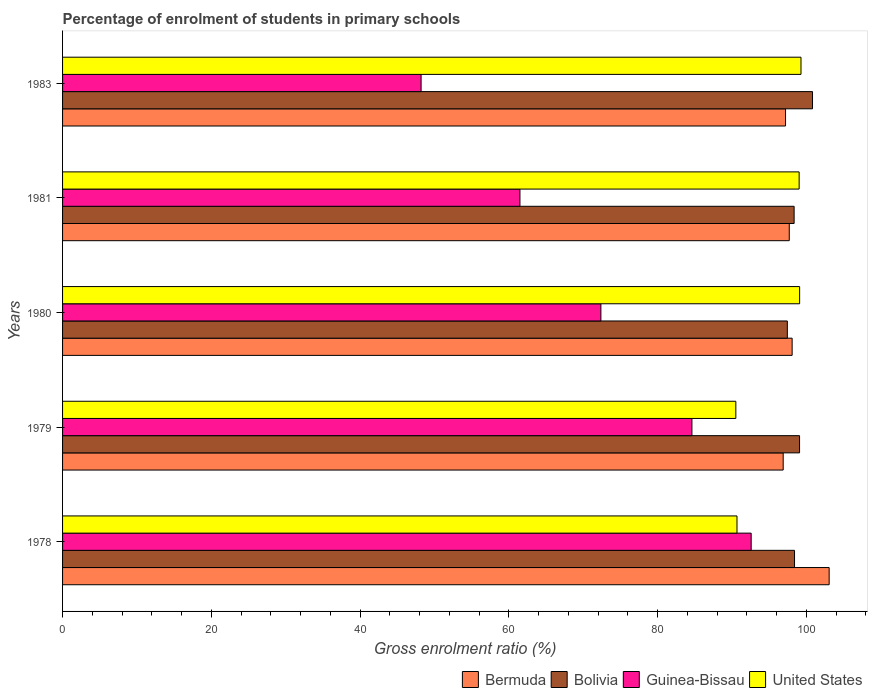How many bars are there on the 1st tick from the top?
Your answer should be compact. 4. What is the label of the 3rd group of bars from the top?
Provide a short and direct response. 1980. What is the percentage of students enrolled in primary schools in Guinea-Bissau in 1978?
Your response must be concise. 92.59. Across all years, what is the maximum percentage of students enrolled in primary schools in Bermuda?
Your response must be concise. 103.08. Across all years, what is the minimum percentage of students enrolled in primary schools in Guinea-Bissau?
Offer a very short reply. 48.21. In which year was the percentage of students enrolled in primary schools in Bermuda minimum?
Keep it short and to the point. 1979. What is the total percentage of students enrolled in primary schools in Bolivia in the graph?
Provide a succinct answer. 494.17. What is the difference between the percentage of students enrolled in primary schools in Bermuda in 1980 and that in 1983?
Your answer should be very brief. 0.89. What is the difference between the percentage of students enrolled in primary schools in Bermuda in 1980 and the percentage of students enrolled in primary schools in Guinea-Bissau in 1983?
Provide a succinct answer. 49.89. What is the average percentage of students enrolled in primary schools in Guinea-Bissau per year?
Offer a very short reply. 71.86. In the year 1980, what is the difference between the percentage of students enrolled in primary schools in Bermuda and percentage of students enrolled in primary schools in Bolivia?
Your response must be concise. 0.65. In how many years, is the percentage of students enrolled in primary schools in United States greater than 16 %?
Your response must be concise. 5. What is the ratio of the percentage of students enrolled in primary schools in Bermuda in 1980 to that in 1981?
Provide a short and direct response. 1. Is the percentage of students enrolled in primary schools in Guinea-Bissau in 1979 less than that in 1980?
Offer a terse response. No. What is the difference between the highest and the second highest percentage of students enrolled in primary schools in Bermuda?
Your response must be concise. 4.98. What is the difference between the highest and the lowest percentage of students enrolled in primary schools in United States?
Ensure brevity in your answer.  8.76. In how many years, is the percentage of students enrolled in primary schools in Guinea-Bissau greater than the average percentage of students enrolled in primary schools in Guinea-Bissau taken over all years?
Offer a terse response. 3. Is the sum of the percentage of students enrolled in primary schools in Guinea-Bissau in 1978 and 1983 greater than the maximum percentage of students enrolled in primary schools in Bermuda across all years?
Your answer should be compact. Yes. What does the 4th bar from the top in 1980 represents?
Your response must be concise. Bermuda. What does the 2nd bar from the bottom in 1979 represents?
Offer a very short reply. Bolivia. Are all the bars in the graph horizontal?
Your answer should be very brief. Yes. Does the graph contain any zero values?
Give a very brief answer. No. Does the graph contain grids?
Your answer should be very brief. No. Where does the legend appear in the graph?
Your response must be concise. Bottom right. How many legend labels are there?
Provide a succinct answer. 4. How are the legend labels stacked?
Your answer should be very brief. Horizontal. What is the title of the graph?
Make the answer very short. Percentage of enrolment of students in primary schools. Does "Brunei Darussalam" appear as one of the legend labels in the graph?
Provide a succinct answer. No. What is the Gross enrolment ratio (%) in Bermuda in 1978?
Your response must be concise. 103.08. What is the Gross enrolment ratio (%) in Bolivia in 1978?
Give a very brief answer. 98.42. What is the Gross enrolment ratio (%) of Guinea-Bissau in 1978?
Provide a short and direct response. 92.59. What is the Gross enrolment ratio (%) in United States in 1978?
Provide a succinct answer. 90.68. What is the Gross enrolment ratio (%) in Bermuda in 1979?
Make the answer very short. 96.9. What is the Gross enrolment ratio (%) of Bolivia in 1979?
Your answer should be very brief. 99.1. What is the Gross enrolment ratio (%) of Guinea-Bissau in 1979?
Give a very brief answer. 84.62. What is the Gross enrolment ratio (%) in United States in 1979?
Make the answer very short. 90.53. What is the Gross enrolment ratio (%) of Bermuda in 1980?
Offer a terse response. 98.1. What is the Gross enrolment ratio (%) in Bolivia in 1980?
Provide a succinct answer. 97.45. What is the Gross enrolment ratio (%) of Guinea-Bissau in 1980?
Provide a short and direct response. 72.38. What is the Gross enrolment ratio (%) of United States in 1980?
Your answer should be compact. 99.11. What is the Gross enrolment ratio (%) of Bermuda in 1981?
Offer a very short reply. 97.71. What is the Gross enrolment ratio (%) of Bolivia in 1981?
Ensure brevity in your answer.  98.37. What is the Gross enrolment ratio (%) in Guinea-Bissau in 1981?
Your answer should be compact. 61.5. What is the Gross enrolment ratio (%) in United States in 1981?
Your response must be concise. 99.04. What is the Gross enrolment ratio (%) of Bermuda in 1983?
Ensure brevity in your answer.  97.21. What is the Gross enrolment ratio (%) of Bolivia in 1983?
Your answer should be very brief. 100.84. What is the Gross enrolment ratio (%) of Guinea-Bissau in 1983?
Make the answer very short. 48.21. What is the Gross enrolment ratio (%) in United States in 1983?
Ensure brevity in your answer.  99.29. Across all years, what is the maximum Gross enrolment ratio (%) of Bermuda?
Your answer should be very brief. 103.08. Across all years, what is the maximum Gross enrolment ratio (%) of Bolivia?
Ensure brevity in your answer.  100.84. Across all years, what is the maximum Gross enrolment ratio (%) in Guinea-Bissau?
Make the answer very short. 92.59. Across all years, what is the maximum Gross enrolment ratio (%) in United States?
Give a very brief answer. 99.29. Across all years, what is the minimum Gross enrolment ratio (%) of Bermuda?
Your answer should be compact. 96.9. Across all years, what is the minimum Gross enrolment ratio (%) of Bolivia?
Your answer should be very brief. 97.45. Across all years, what is the minimum Gross enrolment ratio (%) in Guinea-Bissau?
Offer a terse response. 48.21. Across all years, what is the minimum Gross enrolment ratio (%) in United States?
Keep it short and to the point. 90.53. What is the total Gross enrolment ratio (%) in Bermuda in the graph?
Your answer should be compact. 492.99. What is the total Gross enrolment ratio (%) in Bolivia in the graph?
Offer a very short reply. 494.17. What is the total Gross enrolment ratio (%) of Guinea-Bissau in the graph?
Provide a succinct answer. 359.31. What is the total Gross enrolment ratio (%) of United States in the graph?
Provide a short and direct response. 478.64. What is the difference between the Gross enrolment ratio (%) of Bermuda in 1978 and that in 1979?
Make the answer very short. 6.18. What is the difference between the Gross enrolment ratio (%) in Bolivia in 1978 and that in 1979?
Offer a terse response. -0.68. What is the difference between the Gross enrolment ratio (%) in Guinea-Bissau in 1978 and that in 1979?
Provide a succinct answer. 7.97. What is the difference between the Gross enrolment ratio (%) of United States in 1978 and that in 1979?
Ensure brevity in your answer.  0.16. What is the difference between the Gross enrolment ratio (%) of Bermuda in 1978 and that in 1980?
Keep it short and to the point. 4.98. What is the difference between the Gross enrolment ratio (%) in Bolivia in 1978 and that in 1980?
Your response must be concise. 0.97. What is the difference between the Gross enrolment ratio (%) of Guinea-Bissau in 1978 and that in 1980?
Make the answer very short. 20.21. What is the difference between the Gross enrolment ratio (%) of United States in 1978 and that in 1980?
Ensure brevity in your answer.  -8.42. What is the difference between the Gross enrolment ratio (%) of Bermuda in 1978 and that in 1981?
Offer a terse response. 5.37. What is the difference between the Gross enrolment ratio (%) of Bolivia in 1978 and that in 1981?
Provide a short and direct response. 0.05. What is the difference between the Gross enrolment ratio (%) of Guinea-Bissau in 1978 and that in 1981?
Offer a very short reply. 31.09. What is the difference between the Gross enrolment ratio (%) in United States in 1978 and that in 1981?
Your response must be concise. -8.36. What is the difference between the Gross enrolment ratio (%) of Bermuda in 1978 and that in 1983?
Keep it short and to the point. 5.87. What is the difference between the Gross enrolment ratio (%) of Bolivia in 1978 and that in 1983?
Your response must be concise. -2.42. What is the difference between the Gross enrolment ratio (%) in Guinea-Bissau in 1978 and that in 1983?
Make the answer very short. 44.38. What is the difference between the Gross enrolment ratio (%) in United States in 1978 and that in 1983?
Your answer should be very brief. -8.61. What is the difference between the Gross enrolment ratio (%) in Bermuda in 1979 and that in 1980?
Your response must be concise. -1.2. What is the difference between the Gross enrolment ratio (%) of Bolivia in 1979 and that in 1980?
Keep it short and to the point. 1.64. What is the difference between the Gross enrolment ratio (%) in Guinea-Bissau in 1979 and that in 1980?
Give a very brief answer. 12.24. What is the difference between the Gross enrolment ratio (%) in United States in 1979 and that in 1980?
Make the answer very short. -8.58. What is the difference between the Gross enrolment ratio (%) of Bermuda in 1979 and that in 1981?
Offer a terse response. -0.82. What is the difference between the Gross enrolment ratio (%) of Bolivia in 1979 and that in 1981?
Your answer should be very brief. 0.73. What is the difference between the Gross enrolment ratio (%) of Guinea-Bissau in 1979 and that in 1981?
Ensure brevity in your answer.  23.12. What is the difference between the Gross enrolment ratio (%) in United States in 1979 and that in 1981?
Your response must be concise. -8.51. What is the difference between the Gross enrolment ratio (%) of Bermuda in 1979 and that in 1983?
Your answer should be very brief. -0.32. What is the difference between the Gross enrolment ratio (%) in Bolivia in 1979 and that in 1983?
Your response must be concise. -1.74. What is the difference between the Gross enrolment ratio (%) in Guinea-Bissau in 1979 and that in 1983?
Your answer should be very brief. 36.42. What is the difference between the Gross enrolment ratio (%) in United States in 1979 and that in 1983?
Make the answer very short. -8.76. What is the difference between the Gross enrolment ratio (%) in Bermuda in 1980 and that in 1981?
Offer a very short reply. 0.39. What is the difference between the Gross enrolment ratio (%) of Bolivia in 1980 and that in 1981?
Ensure brevity in your answer.  -0.91. What is the difference between the Gross enrolment ratio (%) of Guinea-Bissau in 1980 and that in 1981?
Provide a succinct answer. 10.88. What is the difference between the Gross enrolment ratio (%) in United States in 1980 and that in 1981?
Provide a short and direct response. 0.07. What is the difference between the Gross enrolment ratio (%) in Bermuda in 1980 and that in 1983?
Your answer should be very brief. 0.89. What is the difference between the Gross enrolment ratio (%) of Bolivia in 1980 and that in 1983?
Ensure brevity in your answer.  -3.38. What is the difference between the Gross enrolment ratio (%) in Guinea-Bissau in 1980 and that in 1983?
Give a very brief answer. 24.18. What is the difference between the Gross enrolment ratio (%) of United States in 1980 and that in 1983?
Keep it short and to the point. -0.18. What is the difference between the Gross enrolment ratio (%) in Bermuda in 1981 and that in 1983?
Give a very brief answer. 0.5. What is the difference between the Gross enrolment ratio (%) in Bolivia in 1981 and that in 1983?
Provide a short and direct response. -2.47. What is the difference between the Gross enrolment ratio (%) in Guinea-Bissau in 1981 and that in 1983?
Ensure brevity in your answer.  13.29. What is the difference between the Gross enrolment ratio (%) in United States in 1981 and that in 1983?
Offer a very short reply. -0.25. What is the difference between the Gross enrolment ratio (%) in Bermuda in 1978 and the Gross enrolment ratio (%) in Bolivia in 1979?
Ensure brevity in your answer.  3.98. What is the difference between the Gross enrolment ratio (%) of Bermuda in 1978 and the Gross enrolment ratio (%) of Guinea-Bissau in 1979?
Offer a terse response. 18.45. What is the difference between the Gross enrolment ratio (%) in Bermuda in 1978 and the Gross enrolment ratio (%) in United States in 1979?
Give a very brief answer. 12.55. What is the difference between the Gross enrolment ratio (%) in Bolivia in 1978 and the Gross enrolment ratio (%) in Guinea-Bissau in 1979?
Your answer should be very brief. 13.8. What is the difference between the Gross enrolment ratio (%) of Bolivia in 1978 and the Gross enrolment ratio (%) of United States in 1979?
Your response must be concise. 7.89. What is the difference between the Gross enrolment ratio (%) in Guinea-Bissau in 1978 and the Gross enrolment ratio (%) in United States in 1979?
Offer a very short reply. 2.06. What is the difference between the Gross enrolment ratio (%) in Bermuda in 1978 and the Gross enrolment ratio (%) in Bolivia in 1980?
Make the answer very short. 5.62. What is the difference between the Gross enrolment ratio (%) of Bermuda in 1978 and the Gross enrolment ratio (%) of Guinea-Bissau in 1980?
Keep it short and to the point. 30.69. What is the difference between the Gross enrolment ratio (%) in Bermuda in 1978 and the Gross enrolment ratio (%) in United States in 1980?
Provide a short and direct response. 3.97. What is the difference between the Gross enrolment ratio (%) of Bolivia in 1978 and the Gross enrolment ratio (%) of Guinea-Bissau in 1980?
Provide a succinct answer. 26.04. What is the difference between the Gross enrolment ratio (%) in Bolivia in 1978 and the Gross enrolment ratio (%) in United States in 1980?
Give a very brief answer. -0.69. What is the difference between the Gross enrolment ratio (%) of Guinea-Bissau in 1978 and the Gross enrolment ratio (%) of United States in 1980?
Give a very brief answer. -6.51. What is the difference between the Gross enrolment ratio (%) of Bermuda in 1978 and the Gross enrolment ratio (%) of Bolivia in 1981?
Keep it short and to the point. 4.71. What is the difference between the Gross enrolment ratio (%) in Bermuda in 1978 and the Gross enrolment ratio (%) in Guinea-Bissau in 1981?
Provide a short and direct response. 41.58. What is the difference between the Gross enrolment ratio (%) in Bermuda in 1978 and the Gross enrolment ratio (%) in United States in 1981?
Provide a succinct answer. 4.04. What is the difference between the Gross enrolment ratio (%) in Bolivia in 1978 and the Gross enrolment ratio (%) in Guinea-Bissau in 1981?
Give a very brief answer. 36.92. What is the difference between the Gross enrolment ratio (%) of Bolivia in 1978 and the Gross enrolment ratio (%) of United States in 1981?
Give a very brief answer. -0.62. What is the difference between the Gross enrolment ratio (%) in Guinea-Bissau in 1978 and the Gross enrolment ratio (%) in United States in 1981?
Provide a succinct answer. -6.45. What is the difference between the Gross enrolment ratio (%) in Bermuda in 1978 and the Gross enrolment ratio (%) in Bolivia in 1983?
Offer a very short reply. 2.24. What is the difference between the Gross enrolment ratio (%) of Bermuda in 1978 and the Gross enrolment ratio (%) of Guinea-Bissau in 1983?
Your response must be concise. 54.87. What is the difference between the Gross enrolment ratio (%) in Bermuda in 1978 and the Gross enrolment ratio (%) in United States in 1983?
Provide a succinct answer. 3.79. What is the difference between the Gross enrolment ratio (%) in Bolivia in 1978 and the Gross enrolment ratio (%) in Guinea-Bissau in 1983?
Offer a terse response. 50.21. What is the difference between the Gross enrolment ratio (%) in Bolivia in 1978 and the Gross enrolment ratio (%) in United States in 1983?
Give a very brief answer. -0.87. What is the difference between the Gross enrolment ratio (%) of Guinea-Bissau in 1978 and the Gross enrolment ratio (%) of United States in 1983?
Make the answer very short. -6.7. What is the difference between the Gross enrolment ratio (%) of Bermuda in 1979 and the Gross enrolment ratio (%) of Bolivia in 1980?
Provide a succinct answer. -0.56. What is the difference between the Gross enrolment ratio (%) in Bermuda in 1979 and the Gross enrolment ratio (%) in Guinea-Bissau in 1980?
Provide a short and direct response. 24.51. What is the difference between the Gross enrolment ratio (%) of Bermuda in 1979 and the Gross enrolment ratio (%) of United States in 1980?
Give a very brief answer. -2.21. What is the difference between the Gross enrolment ratio (%) in Bolivia in 1979 and the Gross enrolment ratio (%) in Guinea-Bissau in 1980?
Your answer should be compact. 26.71. What is the difference between the Gross enrolment ratio (%) in Bolivia in 1979 and the Gross enrolment ratio (%) in United States in 1980?
Offer a terse response. -0.01. What is the difference between the Gross enrolment ratio (%) in Guinea-Bissau in 1979 and the Gross enrolment ratio (%) in United States in 1980?
Ensure brevity in your answer.  -14.48. What is the difference between the Gross enrolment ratio (%) in Bermuda in 1979 and the Gross enrolment ratio (%) in Bolivia in 1981?
Your response must be concise. -1.47. What is the difference between the Gross enrolment ratio (%) in Bermuda in 1979 and the Gross enrolment ratio (%) in Guinea-Bissau in 1981?
Your answer should be very brief. 35.39. What is the difference between the Gross enrolment ratio (%) in Bermuda in 1979 and the Gross enrolment ratio (%) in United States in 1981?
Keep it short and to the point. -2.14. What is the difference between the Gross enrolment ratio (%) in Bolivia in 1979 and the Gross enrolment ratio (%) in Guinea-Bissau in 1981?
Provide a short and direct response. 37.6. What is the difference between the Gross enrolment ratio (%) in Bolivia in 1979 and the Gross enrolment ratio (%) in United States in 1981?
Give a very brief answer. 0.06. What is the difference between the Gross enrolment ratio (%) in Guinea-Bissau in 1979 and the Gross enrolment ratio (%) in United States in 1981?
Give a very brief answer. -14.42. What is the difference between the Gross enrolment ratio (%) of Bermuda in 1979 and the Gross enrolment ratio (%) of Bolivia in 1983?
Make the answer very short. -3.94. What is the difference between the Gross enrolment ratio (%) in Bermuda in 1979 and the Gross enrolment ratio (%) in Guinea-Bissau in 1983?
Keep it short and to the point. 48.69. What is the difference between the Gross enrolment ratio (%) of Bermuda in 1979 and the Gross enrolment ratio (%) of United States in 1983?
Ensure brevity in your answer.  -2.39. What is the difference between the Gross enrolment ratio (%) of Bolivia in 1979 and the Gross enrolment ratio (%) of Guinea-Bissau in 1983?
Offer a terse response. 50.89. What is the difference between the Gross enrolment ratio (%) of Bolivia in 1979 and the Gross enrolment ratio (%) of United States in 1983?
Your response must be concise. -0.19. What is the difference between the Gross enrolment ratio (%) of Guinea-Bissau in 1979 and the Gross enrolment ratio (%) of United States in 1983?
Give a very brief answer. -14.66. What is the difference between the Gross enrolment ratio (%) of Bermuda in 1980 and the Gross enrolment ratio (%) of Bolivia in 1981?
Your answer should be compact. -0.27. What is the difference between the Gross enrolment ratio (%) of Bermuda in 1980 and the Gross enrolment ratio (%) of Guinea-Bissau in 1981?
Provide a short and direct response. 36.6. What is the difference between the Gross enrolment ratio (%) in Bermuda in 1980 and the Gross enrolment ratio (%) in United States in 1981?
Offer a very short reply. -0.94. What is the difference between the Gross enrolment ratio (%) in Bolivia in 1980 and the Gross enrolment ratio (%) in Guinea-Bissau in 1981?
Make the answer very short. 35.95. What is the difference between the Gross enrolment ratio (%) in Bolivia in 1980 and the Gross enrolment ratio (%) in United States in 1981?
Provide a succinct answer. -1.59. What is the difference between the Gross enrolment ratio (%) of Guinea-Bissau in 1980 and the Gross enrolment ratio (%) of United States in 1981?
Provide a succinct answer. -26.66. What is the difference between the Gross enrolment ratio (%) of Bermuda in 1980 and the Gross enrolment ratio (%) of Bolivia in 1983?
Offer a very short reply. -2.74. What is the difference between the Gross enrolment ratio (%) of Bermuda in 1980 and the Gross enrolment ratio (%) of Guinea-Bissau in 1983?
Provide a succinct answer. 49.89. What is the difference between the Gross enrolment ratio (%) in Bermuda in 1980 and the Gross enrolment ratio (%) in United States in 1983?
Your response must be concise. -1.19. What is the difference between the Gross enrolment ratio (%) of Bolivia in 1980 and the Gross enrolment ratio (%) of Guinea-Bissau in 1983?
Your answer should be very brief. 49.25. What is the difference between the Gross enrolment ratio (%) in Bolivia in 1980 and the Gross enrolment ratio (%) in United States in 1983?
Make the answer very short. -1.83. What is the difference between the Gross enrolment ratio (%) of Guinea-Bissau in 1980 and the Gross enrolment ratio (%) of United States in 1983?
Ensure brevity in your answer.  -26.9. What is the difference between the Gross enrolment ratio (%) of Bermuda in 1981 and the Gross enrolment ratio (%) of Bolivia in 1983?
Give a very brief answer. -3.13. What is the difference between the Gross enrolment ratio (%) of Bermuda in 1981 and the Gross enrolment ratio (%) of Guinea-Bissau in 1983?
Offer a terse response. 49.5. What is the difference between the Gross enrolment ratio (%) of Bermuda in 1981 and the Gross enrolment ratio (%) of United States in 1983?
Ensure brevity in your answer.  -1.58. What is the difference between the Gross enrolment ratio (%) of Bolivia in 1981 and the Gross enrolment ratio (%) of Guinea-Bissau in 1983?
Your response must be concise. 50.16. What is the difference between the Gross enrolment ratio (%) of Bolivia in 1981 and the Gross enrolment ratio (%) of United States in 1983?
Provide a short and direct response. -0.92. What is the difference between the Gross enrolment ratio (%) in Guinea-Bissau in 1981 and the Gross enrolment ratio (%) in United States in 1983?
Offer a terse response. -37.79. What is the average Gross enrolment ratio (%) of Bermuda per year?
Your response must be concise. 98.6. What is the average Gross enrolment ratio (%) of Bolivia per year?
Your answer should be compact. 98.83. What is the average Gross enrolment ratio (%) in Guinea-Bissau per year?
Provide a succinct answer. 71.86. What is the average Gross enrolment ratio (%) of United States per year?
Your answer should be very brief. 95.73. In the year 1978, what is the difference between the Gross enrolment ratio (%) in Bermuda and Gross enrolment ratio (%) in Bolivia?
Provide a succinct answer. 4.66. In the year 1978, what is the difference between the Gross enrolment ratio (%) in Bermuda and Gross enrolment ratio (%) in Guinea-Bissau?
Your response must be concise. 10.49. In the year 1978, what is the difference between the Gross enrolment ratio (%) in Bermuda and Gross enrolment ratio (%) in United States?
Your answer should be very brief. 12.39. In the year 1978, what is the difference between the Gross enrolment ratio (%) in Bolivia and Gross enrolment ratio (%) in Guinea-Bissau?
Your answer should be very brief. 5.83. In the year 1978, what is the difference between the Gross enrolment ratio (%) in Bolivia and Gross enrolment ratio (%) in United States?
Keep it short and to the point. 7.74. In the year 1978, what is the difference between the Gross enrolment ratio (%) of Guinea-Bissau and Gross enrolment ratio (%) of United States?
Your answer should be compact. 1.91. In the year 1979, what is the difference between the Gross enrolment ratio (%) of Bermuda and Gross enrolment ratio (%) of Bolivia?
Provide a succinct answer. -2.2. In the year 1979, what is the difference between the Gross enrolment ratio (%) in Bermuda and Gross enrolment ratio (%) in Guinea-Bissau?
Ensure brevity in your answer.  12.27. In the year 1979, what is the difference between the Gross enrolment ratio (%) of Bermuda and Gross enrolment ratio (%) of United States?
Provide a short and direct response. 6.37. In the year 1979, what is the difference between the Gross enrolment ratio (%) in Bolivia and Gross enrolment ratio (%) in Guinea-Bissau?
Offer a terse response. 14.47. In the year 1979, what is the difference between the Gross enrolment ratio (%) in Bolivia and Gross enrolment ratio (%) in United States?
Ensure brevity in your answer.  8.57. In the year 1979, what is the difference between the Gross enrolment ratio (%) in Guinea-Bissau and Gross enrolment ratio (%) in United States?
Keep it short and to the point. -5.9. In the year 1980, what is the difference between the Gross enrolment ratio (%) in Bermuda and Gross enrolment ratio (%) in Bolivia?
Make the answer very short. 0.65. In the year 1980, what is the difference between the Gross enrolment ratio (%) of Bermuda and Gross enrolment ratio (%) of Guinea-Bissau?
Your response must be concise. 25.71. In the year 1980, what is the difference between the Gross enrolment ratio (%) of Bermuda and Gross enrolment ratio (%) of United States?
Give a very brief answer. -1.01. In the year 1980, what is the difference between the Gross enrolment ratio (%) in Bolivia and Gross enrolment ratio (%) in Guinea-Bissau?
Your answer should be compact. 25.07. In the year 1980, what is the difference between the Gross enrolment ratio (%) in Bolivia and Gross enrolment ratio (%) in United States?
Ensure brevity in your answer.  -1.65. In the year 1980, what is the difference between the Gross enrolment ratio (%) in Guinea-Bissau and Gross enrolment ratio (%) in United States?
Your response must be concise. -26.72. In the year 1981, what is the difference between the Gross enrolment ratio (%) in Bermuda and Gross enrolment ratio (%) in Bolivia?
Your answer should be very brief. -0.65. In the year 1981, what is the difference between the Gross enrolment ratio (%) in Bermuda and Gross enrolment ratio (%) in Guinea-Bissau?
Keep it short and to the point. 36.21. In the year 1981, what is the difference between the Gross enrolment ratio (%) in Bermuda and Gross enrolment ratio (%) in United States?
Keep it short and to the point. -1.33. In the year 1981, what is the difference between the Gross enrolment ratio (%) of Bolivia and Gross enrolment ratio (%) of Guinea-Bissau?
Ensure brevity in your answer.  36.86. In the year 1981, what is the difference between the Gross enrolment ratio (%) of Bolivia and Gross enrolment ratio (%) of United States?
Provide a short and direct response. -0.67. In the year 1981, what is the difference between the Gross enrolment ratio (%) of Guinea-Bissau and Gross enrolment ratio (%) of United States?
Your response must be concise. -37.54. In the year 1983, what is the difference between the Gross enrolment ratio (%) of Bermuda and Gross enrolment ratio (%) of Bolivia?
Ensure brevity in your answer.  -3.63. In the year 1983, what is the difference between the Gross enrolment ratio (%) in Bermuda and Gross enrolment ratio (%) in Guinea-Bissau?
Your response must be concise. 49. In the year 1983, what is the difference between the Gross enrolment ratio (%) of Bermuda and Gross enrolment ratio (%) of United States?
Provide a short and direct response. -2.08. In the year 1983, what is the difference between the Gross enrolment ratio (%) in Bolivia and Gross enrolment ratio (%) in Guinea-Bissau?
Keep it short and to the point. 52.63. In the year 1983, what is the difference between the Gross enrolment ratio (%) of Bolivia and Gross enrolment ratio (%) of United States?
Offer a terse response. 1.55. In the year 1983, what is the difference between the Gross enrolment ratio (%) of Guinea-Bissau and Gross enrolment ratio (%) of United States?
Your answer should be very brief. -51.08. What is the ratio of the Gross enrolment ratio (%) of Bermuda in 1978 to that in 1979?
Provide a succinct answer. 1.06. What is the ratio of the Gross enrolment ratio (%) in Guinea-Bissau in 1978 to that in 1979?
Keep it short and to the point. 1.09. What is the ratio of the Gross enrolment ratio (%) of United States in 1978 to that in 1979?
Your answer should be compact. 1. What is the ratio of the Gross enrolment ratio (%) in Bermuda in 1978 to that in 1980?
Ensure brevity in your answer.  1.05. What is the ratio of the Gross enrolment ratio (%) in Bolivia in 1978 to that in 1980?
Ensure brevity in your answer.  1.01. What is the ratio of the Gross enrolment ratio (%) of Guinea-Bissau in 1978 to that in 1980?
Your response must be concise. 1.28. What is the ratio of the Gross enrolment ratio (%) of United States in 1978 to that in 1980?
Your answer should be compact. 0.92. What is the ratio of the Gross enrolment ratio (%) of Bermuda in 1978 to that in 1981?
Your response must be concise. 1.05. What is the ratio of the Gross enrolment ratio (%) of Bolivia in 1978 to that in 1981?
Offer a terse response. 1. What is the ratio of the Gross enrolment ratio (%) in Guinea-Bissau in 1978 to that in 1981?
Provide a succinct answer. 1.51. What is the ratio of the Gross enrolment ratio (%) in United States in 1978 to that in 1981?
Your answer should be very brief. 0.92. What is the ratio of the Gross enrolment ratio (%) of Bermuda in 1978 to that in 1983?
Make the answer very short. 1.06. What is the ratio of the Gross enrolment ratio (%) in Bolivia in 1978 to that in 1983?
Keep it short and to the point. 0.98. What is the ratio of the Gross enrolment ratio (%) in Guinea-Bissau in 1978 to that in 1983?
Give a very brief answer. 1.92. What is the ratio of the Gross enrolment ratio (%) in United States in 1978 to that in 1983?
Provide a succinct answer. 0.91. What is the ratio of the Gross enrolment ratio (%) in Bermuda in 1979 to that in 1980?
Make the answer very short. 0.99. What is the ratio of the Gross enrolment ratio (%) in Bolivia in 1979 to that in 1980?
Your answer should be very brief. 1.02. What is the ratio of the Gross enrolment ratio (%) in Guinea-Bissau in 1979 to that in 1980?
Provide a short and direct response. 1.17. What is the ratio of the Gross enrolment ratio (%) in United States in 1979 to that in 1980?
Your response must be concise. 0.91. What is the ratio of the Gross enrolment ratio (%) in Bolivia in 1979 to that in 1981?
Make the answer very short. 1.01. What is the ratio of the Gross enrolment ratio (%) of Guinea-Bissau in 1979 to that in 1981?
Your answer should be very brief. 1.38. What is the ratio of the Gross enrolment ratio (%) of United States in 1979 to that in 1981?
Make the answer very short. 0.91. What is the ratio of the Gross enrolment ratio (%) of Bolivia in 1979 to that in 1983?
Offer a terse response. 0.98. What is the ratio of the Gross enrolment ratio (%) of Guinea-Bissau in 1979 to that in 1983?
Offer a terse response. 1.76. What is the ratio of the Gross enrolment ratio (%) in United States in 1979 to that in 1983?
Ensure brevity in your answer.  0.91. What is the ratio of the Gross enrolment ratio (%) in Guinea-Bissau in 1980 to that in 1981?
Your answer should be compact. 1.18. What is the ratio of the Gross enrolment ratio (%) of Bermuda in 1980 to that in 1983?
Keep it short and to the point. 1.01. What is the ratio of the Gross enrolment ratio (%) in Bolivia in 1980 to that in 1983?
Make the answer very short. 0.97. What is the ratio of the Gross enrolment ratio (%) of Guinea-Bissau in 1980 to that in 1983?
Offer a terse response. 1.5. What is the ratio of the Gross enrolment ratio (%) of Bermuda in 1981 to that in 1983?
Your answer should be compact. 1.01. What is the ratio of the Gross enrolment ratio (%) of Bolivia in 1981 to that in 1983?
Your answer should be very brief. 0.98. What is the ratio of the Gross enrolment ratio (%) in Guinea-Bissau in 1981 to that in 1983?
Your answer should be compact. 1.28. What is the difference between the highest and the second highest Gross enrolment ratio (%) in Bermuda?
Ensure brevity in your answer.  4.98. What is the difference between the highest and the second highest Gross enrolment ratio (%) of Bolivia?
Give a very brief answer. 1.74. What is the difference between the highest and the second highest Gross enrolment ratio (%) of Guinea-Bissau?
Provide a succinct answer. 7.97. What is the difference between the highest and the second highest Gross enrolment ratio (%) in United States?
Your answer should be compact. 0.18. What is the difference between the highest and the lowest Gross enrolment ratio (%) in Bermuda?
Provide a short and direct response. 6.18. What is the difference between the highest and the lowest Gross enrolment ratio (%) of Bolivia?
Offer a terse response. 3.38. What is the difference between the highest and the lowest Gross enrolment ratio (%) of Guinea-Bissau?
Your answer should be very brief. 44.38. What is the difference between the highest and the lowest Gross enrolment ratio (%) in United States?
Provide a succinct answer. 8.76. 